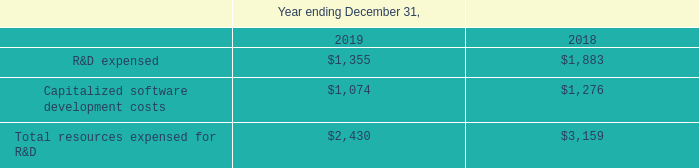To keep pace with client and market demand, we maintain an ongoing program of new product development.
Our software engineers are responsible for creating and building our software products. They do so by combining their expertise with input from our sales, marketing and product management groups as to market trends and needs. Our software engineers design and write software and manage its testing and quality assurance. We utilize third-party software developers both domestically and overseas working under our supervision to supplement our software engineers. Using these external software developers in a strategic manner allows us to access highly skilled labor pools, maintain a 24-hour development schedule, decrease time to market, and minimize programming costs.
All phases of research and development, or R&D, including scope approval, functional and implementation design, object modeling and programming, are subject to extensive internal quality assurance testing. We maintain an ongoing focus on improving our quality assurance testing infrastructure and practices. Technical reporting and client support feedback confirm the continuing positive effect of our ongoing enhancement of research and development and quality assurance processes.
Our EFT Arcus product is hosted by third-party cloud services providers. We rely upon those third parties, such as Microsoft Azure, for the continued development and enhancement of their cloud services infrastructures on which our products are hosted. We do not perform significant research and development of cloud services infrastructures using our own personnel.
Our R&D expenditures profile has been as follows ($ in thousands):
Our total R&D expenditures decreased 23% in 2019 as compared to 2018 primarily due to fewer employed software engineers and technical personnel.
Total resources expended for R&D serves to illustrate our total corporate efforts to improve our existing products and to develop new products regardless of whether or not our expenditures for those efforts were expensed or capitalized. Total resources expended for R&D is not a measure of financial performance under GAAP and should not be considered a substitute for R&D expense and capitalized software development costs individually. While we believe the non-GAAP total resources expended for R&D amount provides useful supplemental information regarding our overall corporate product improvement and new product creation activities, there are limitations associated with the use of this non-GAAP measurement. Total resources expended for R&D is a non-GAAP measure not prepared in accordance with GAAP and may not be comparable to similarly titled measures of other companies since there is no standard for preparing this non-GAAP measure. As a result, this non-GAAP measure of total resources expended for R&D has limitations and should not be considered in isolation from, or as a substitute for, R&D expense and capitalized software development costs individually.
Research and Development
By how much did the firm's R&D expenditures decrease by in 2019 as compared to 2018?
Answer scale should be: percent. 23. What is the purpose of including "Total resources expended for R&D" in the table? Total resources expended for r&d serves to illustrate our total corporate efforts to improve our existing products and to develop new products regardless of whether or not our expenditures for those efforts were expensed or capitalized. By how much did the firm's capitalized software development costs decrease by in 2019 as compared to 2018?
Answer scale should be: percent. (1,276-1,074)/1,276
Answer: 15.83. What is the limitation of using total resources expensed for R&D? Total resources expended for r&d is a non-gaap measure not prepared in accordance with gaap and may not be comparable to similarly titled measures of other companies since there is no standard for preparing this non-gaap measure. What is the difference between the R&D expensed in 2019 and 2018?
Answer scale should be: thousand.  $1,355-$1,883 
Answer: -528. What is the difference between the total resources expensed for R&D in 2019 and 2018?
Answer scale should be: thousand. $2,430-$3,159
Answer: -729. 